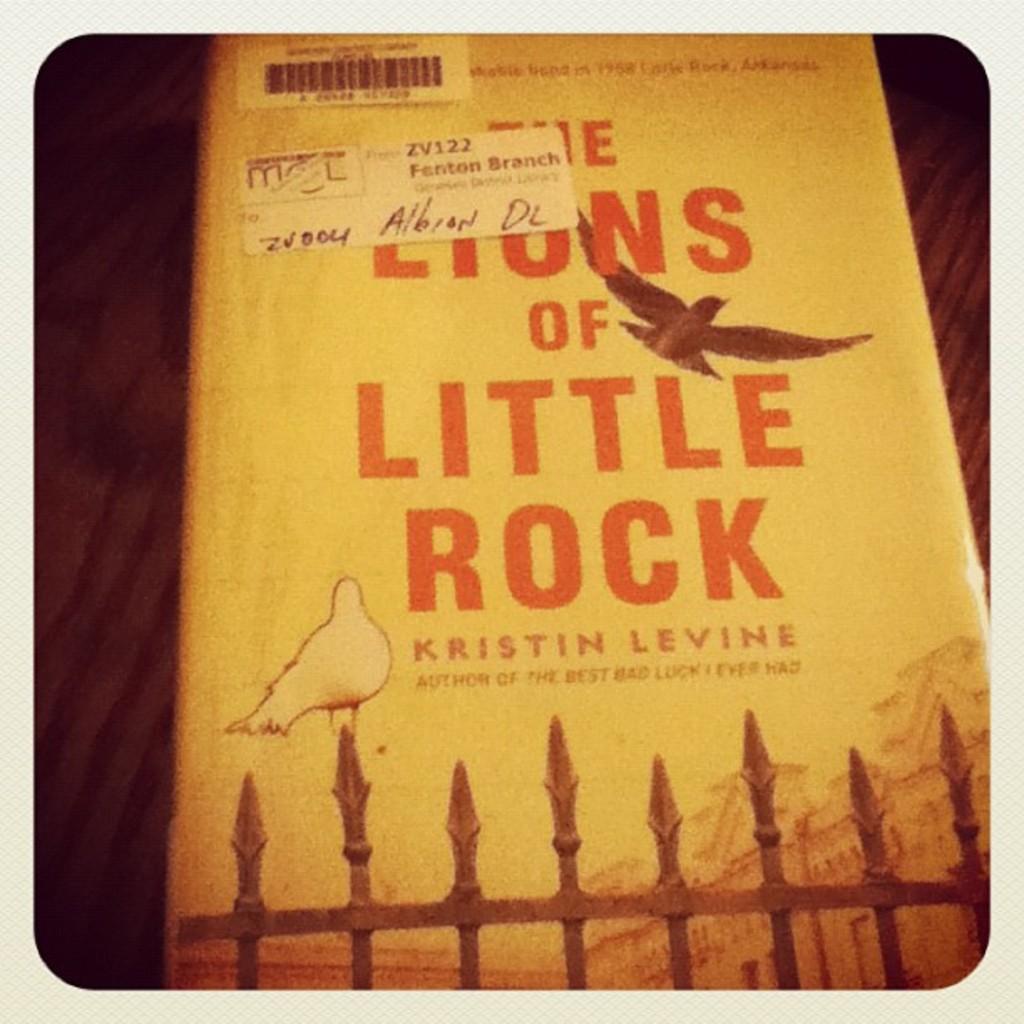Who wrote, "the lions of little rock"?
Give a very brief answer. Kristin levine. What library branch is this book from?
Keep it short and to the point. Fenton. 